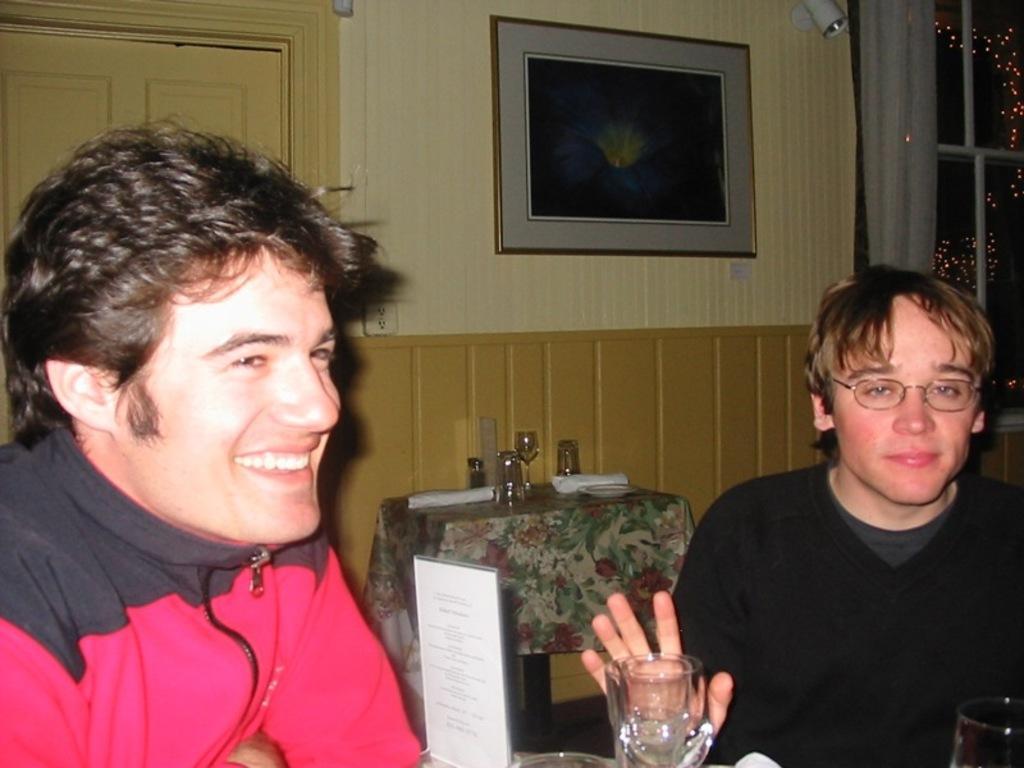Describe this image in one or two sentences. In this image, there are a few people. We can see some objects like glasses and a board with some text at the bottom. We can also see a table covered with a cloth and some objects are on it. We can see the wall with a frame and some objects. We can also see a door and the window. We can also see some cloth and some lights. 